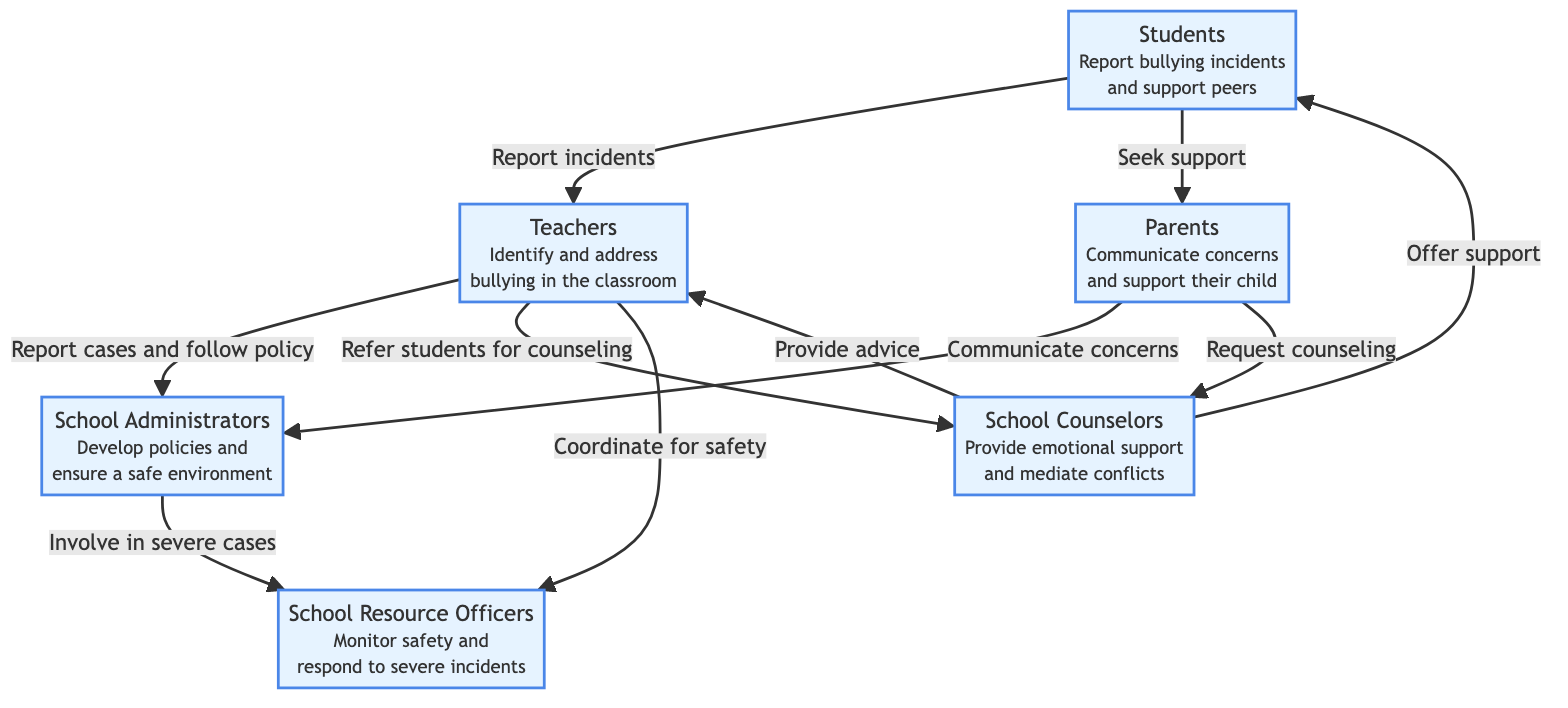What are the roles of students in combating bullying? According to the diagram, students have two main responsibilities: they report bullying incidents and support their peers. These roles are clearly defined under the "Students" node in the diagram.
Answer: Report bullying incidents and support peers How many stakeholders are identified in this diagram? The diagram identifies six different stakeholders involved in combating bullying, which are Students, Teachers, Parents, School Counselors, School Administrators, and School Resource Officers. By counting each node in the diagram, we can determine the total.
Answer: Six Who do teachers refer students to for counseling? According to the diagram, teachers refer students for counseling to School Counselors. This relationship is indicated by an arrow leading from the "Teachers" node to the "School Counselors" node.
Answer: School Counselors What is the role of parents in relation to school administrators? Parents communicate concerns to school administrators. This relationship is displayed by an arrow connecting the "Parents" node to the "School Administrators" node.
Answer: Communicate concerns What action do school counselors provide towards students? School Counselors offer emotional support to students, as indicated under the "School Counselors" node in the diagram.
Answer: Provide emotional support How do school administrators respond to severe cases of bullying? School Administrators involve School Resource Officers in severe cases of bullying. This is shown by the direct link between the "School Administrators" node and the "School Resource Officers" node.
Answer: Involve School Resource Officers 